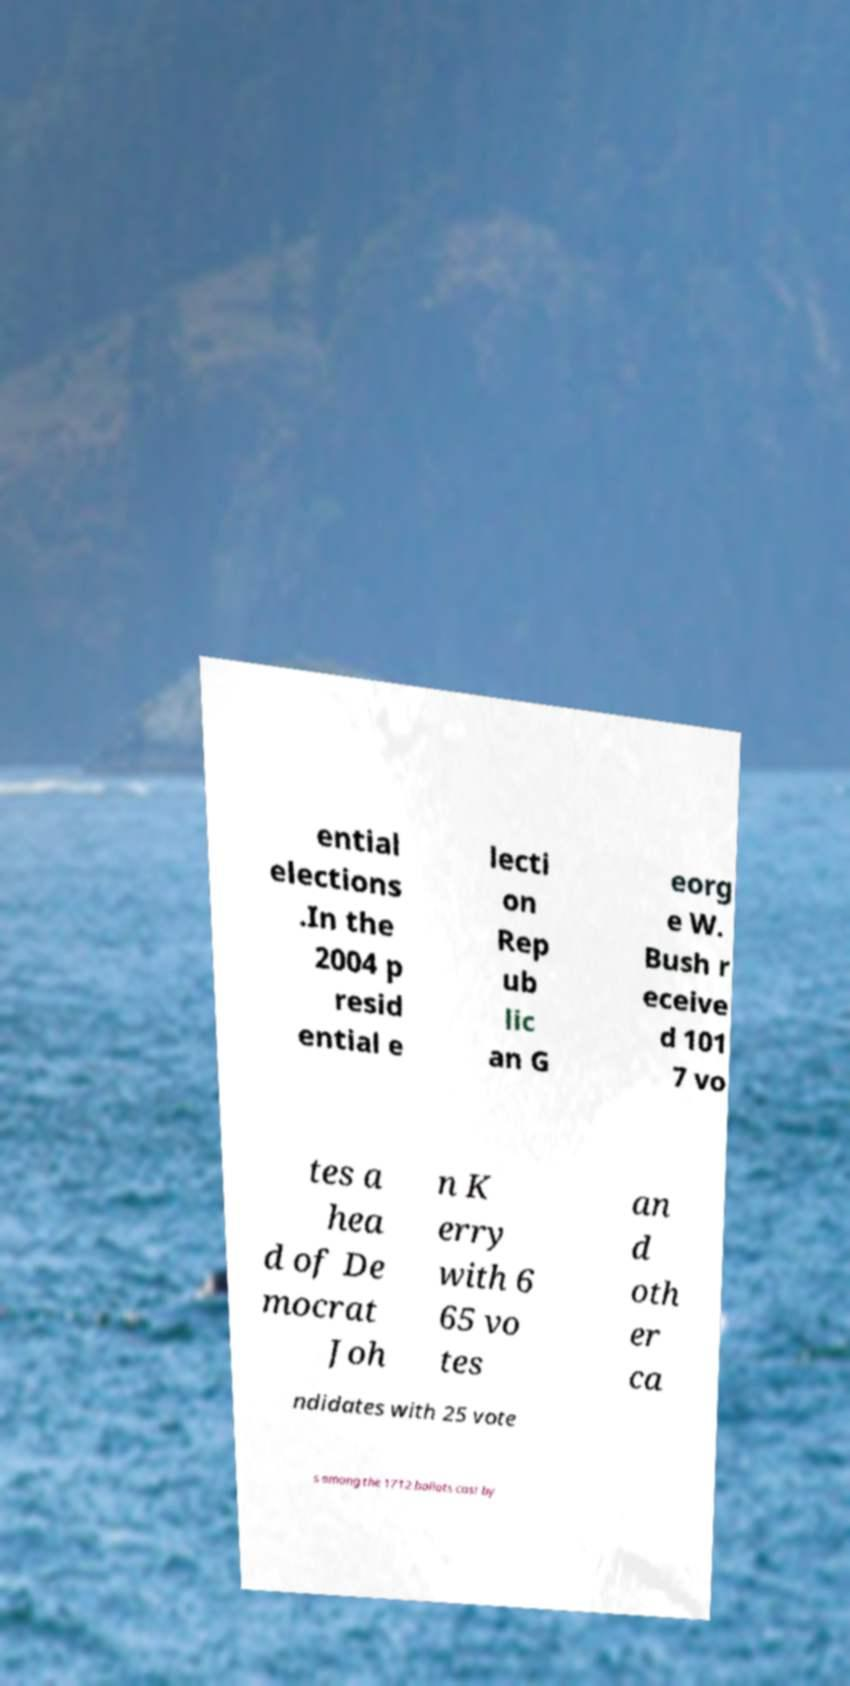What messages or text are displayed in this image? I need them in a readable, typed format. ential elections .In the 2004 p resid ential e lecti on Rep ub lic an G eorg e W. Bush r eceive d 101 7 vo tes a hea d of De mocrat Joh n K erry with 6 65 vo tes an d oth er ca ndidates with 25 vote s among the 1712 ballots cast by 